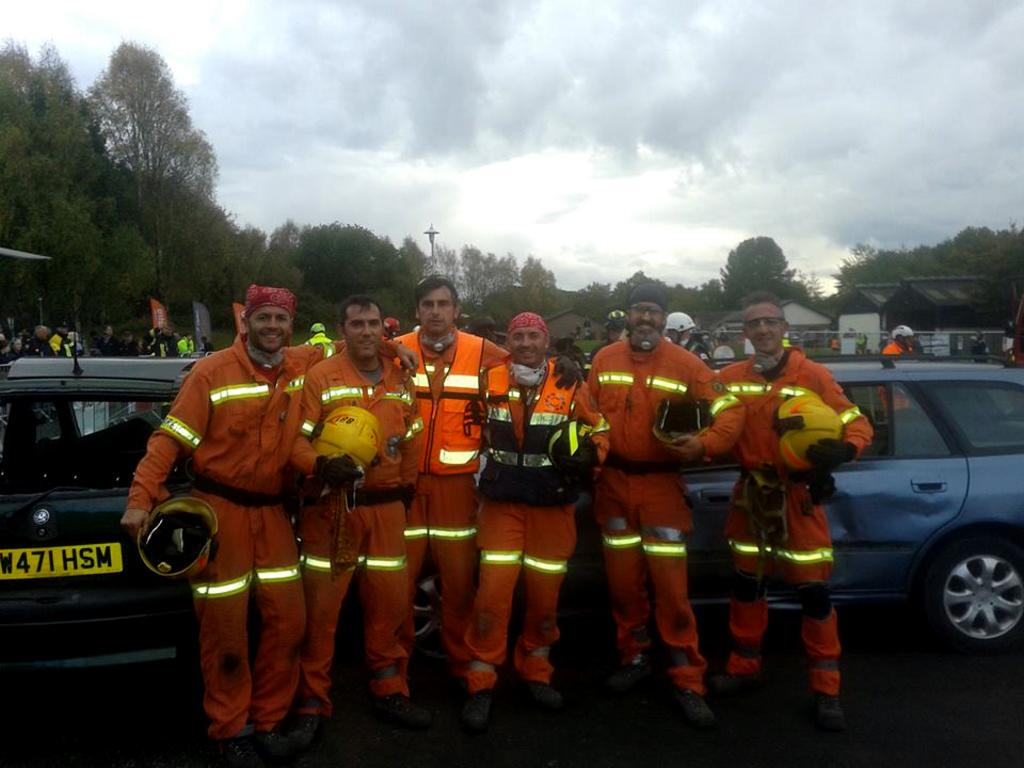What is the main subject in the center of the image? There are people in the center of the image. What can be seen on the right side of the image? There are cars on the right side of the image. What can be seen on the left side of the image? There are cars on the left side of the image. What type of vegetation is present in the center of the image? There are trees in the center of the image. What type of straw is being used by the people in the image? There is no straw present in the image. What type of silk clothing are the people wearing in the image? There is no silk clothing visible in the image. 